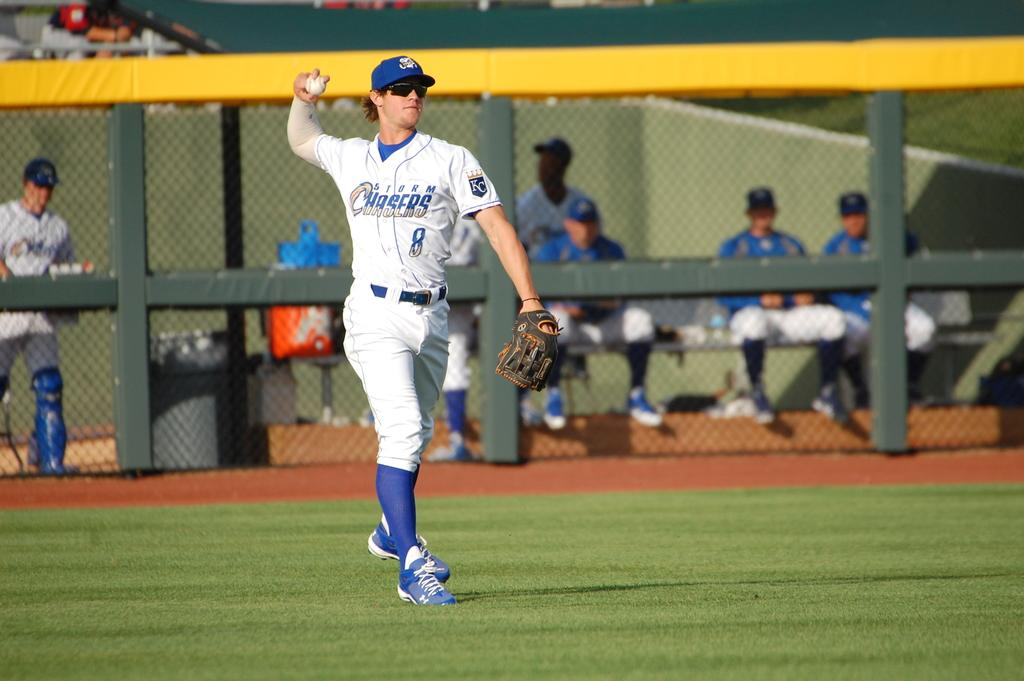<image>
Create a compact narrative representing the image presented. A baseball player has the word Storm Chasers on his shirt. 